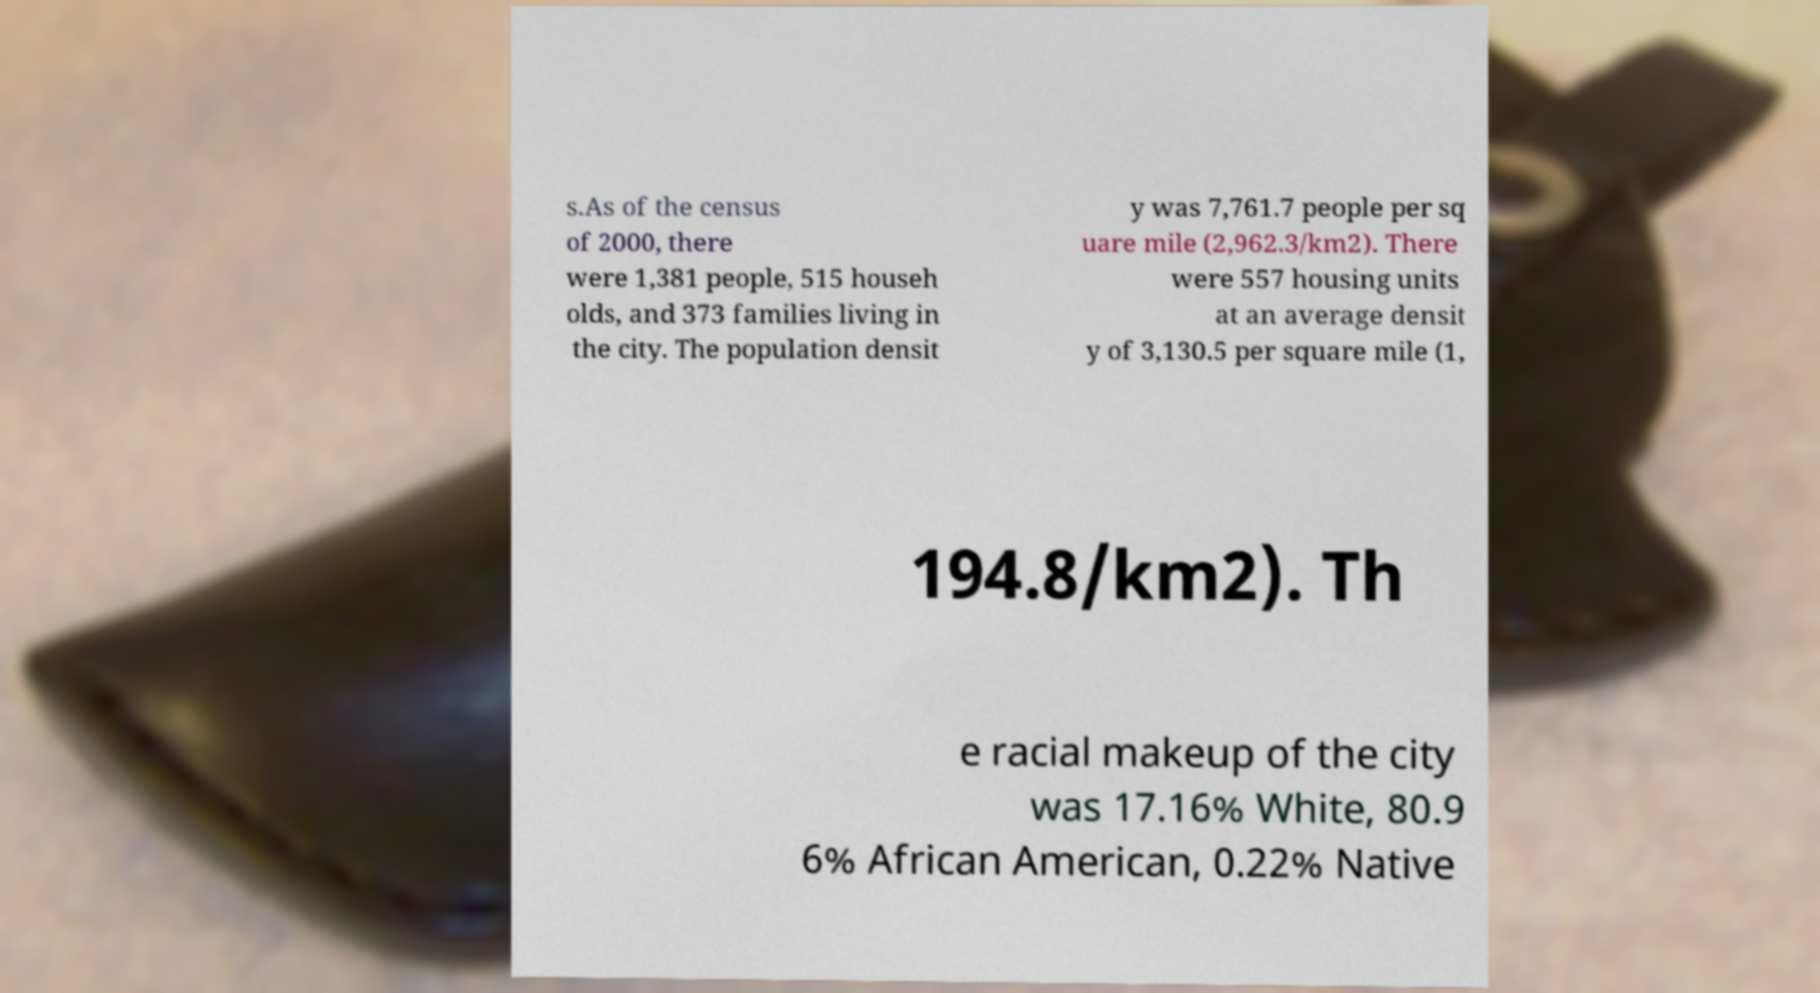Please identify and transcribe the text found in this image. s.As of the census of 2000, there were 1,381 people, 515 househ olds, and 373 families living in the city. The population densit y was 7,761.7 people per sq uare mile (2,962.3/km2). There were 557 housing units at an average densit y of 3,130.5 per square mile (1, 194.8/km2). Th e racial makeup of the city was 17.16% White, 80.9 6% African American, 0.22% Native 